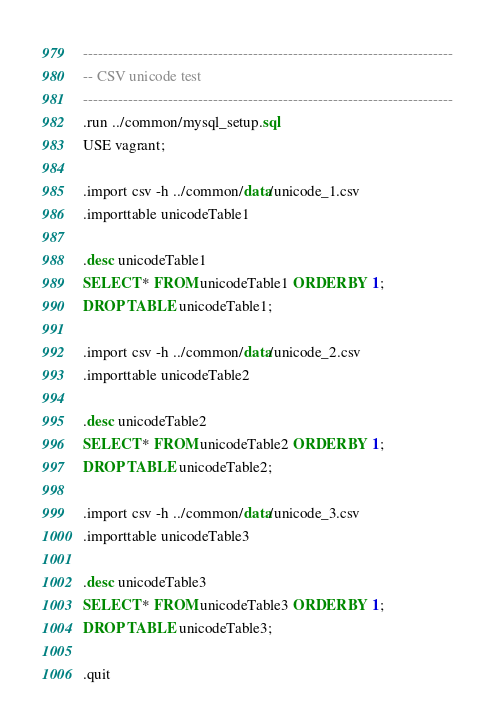Convert code to text. <code><loc_0><loc_0><loc_500><loc_500><_SQL_>--------------------------------------------------------------------------
-- CSV unicode test
--------------------------------------------------------------------------
.run ../common/mysql_setup.sql
USE vagrant;

.import csv -h ../common/data/unicode_1.csv
.importtable unicodeTable1

.desc unicodeTable1
SELECT * FROM unicodeTable1 ORDER BY 1;
DROP TABLE unicodeTable1;

.import csv -h ../common/data/unicode_2.csv
.importtable unicodeTable2

.desc unicodeTable2
SELECT * FROM unicodeTable2 ORDER BY 1;
DROP TABLE unicodeTable2;

.import csv -h ../common/data/unicode_3.csv
.importtable unicodeTable3

.desc unicodeTable3
SELECT * FROM unicodeTable3 ORDER BY 1;
DROP TABLE unicodeTable3;

.quit

</code> 